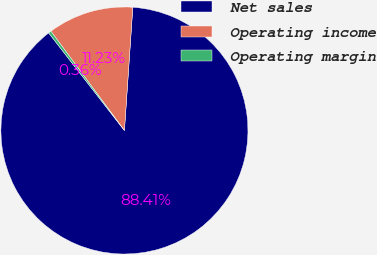<chart> <loc_0><loc_0><loc_500><loc_500><pie_chart><fcel>Net sales<fcel>Operating income<fcel>Operating margin<nl><fcel>88.41%<fcel>11.23%<fcel>0.36%<nl></chart> 